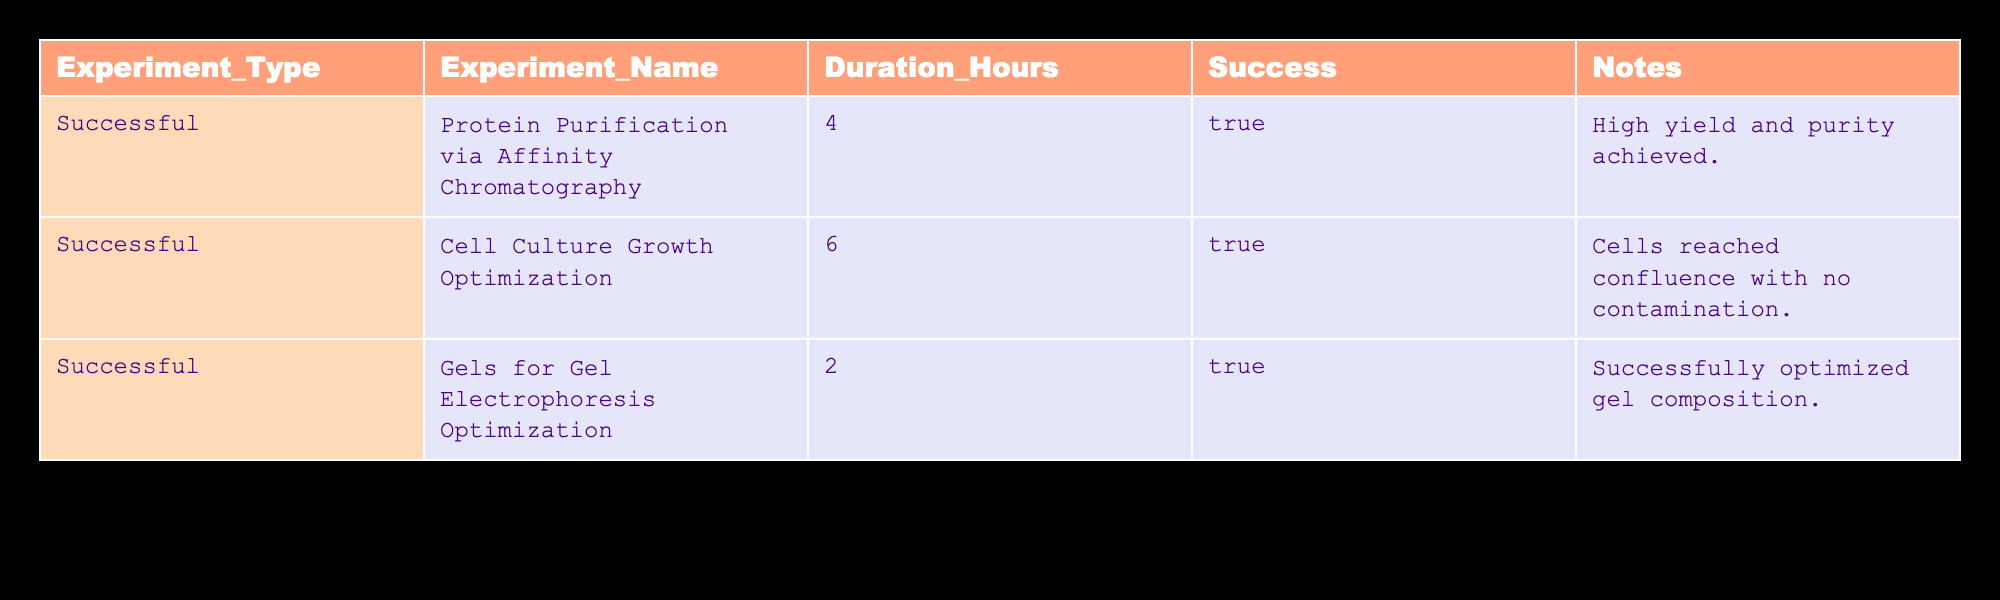What is the total duration of all successful experiments? The table lists three successful experiments with durations of 4 hours, 6 hours, and 2 hours. Adding these durations gives a total of (4 + 6 + 2) = 12 hours.
Answer: 12 hours Which experiment had the highest duration? Looking through the duration hours column, the longest duration is 6 hours, which corresponds to the "Cell Culture Growth Optimization" experiment.
Answer: Cell Culture Growth Optimization How many successful experiments are there in total? The table states that all three experiments listed are successful. Therefore, the total number of successful experiments is 3.
Answer: 3 Is there any experiment that resulted in a high yield and purity? The note for the "Protein Purification via Affinity Chromatography" experiment clearly states that a high yield and purity were achieved. Therefore, the statement is true.
Answer: Yes What is the average duration of the successful experiments? To find the average, sum the durations of the successful experiments (4 + 6 + 2) = 12, and divide by the number of successful experiments (3): 12 / 3 = 4 hours.
Answer: 4 hours How much longer, on average, is the "Cell Culture Growth Optimization" experiment compared to the "Gels for Gel Electrophoresis Optimization"? The duration for "Cell Culture Growth Optimization" is 6 hours, while for "Gels for Gel Electrophoresis Optimization" it is 2 hours. The difference is 6 - 2 = 4 hours. To find the average, divide this difference by 2, since we are comparing two experiments: 4 / 2 = 2 hours.
Answer: 2 hours Is it true that all successful experiments involved optimization processes? The experiments include "Protein Purification via Affinity Chromatography," which does not mention optimization in the notes, thus it does not satisfy the condition. Therefore, the statement is false.
Answer: No What percentage of the total duration was spent on the "Gels for Gel Electrophoresis Optimization"? The duration of the "Gels for Gel Electrophoresis Optimization" is 2 hours. The total duration of all successful experiments is 12 hours. To find the percentage: (2 / 12) * 100 = 16.67%.
Answer: 16.67% 